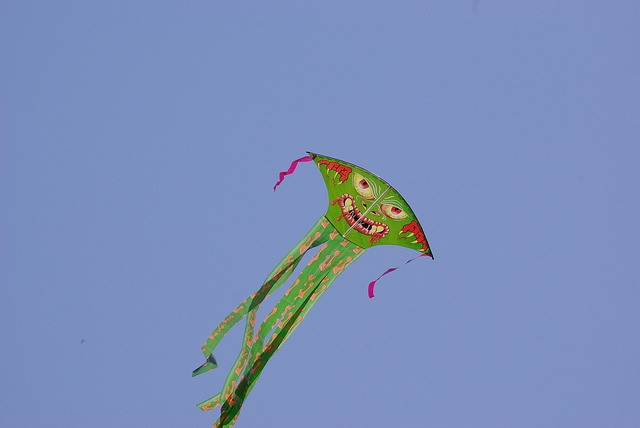Describe the objects in this image and their specific colors. I can see a kite in gray, green, darkgreen, and tan tones in this image. 